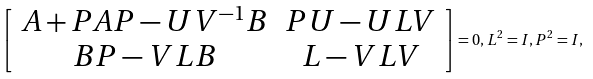Convert formula to latex. <formula><loc_0><loc_0><loc_500><loc_500>\left [ \begin{array} { c c } A + P A P - U V ^ { - 1 } B & P U - U L V \\ B P - V L B & L - V L V \end{array} \right ] = 0 , L ^ { 2 } = I , P ^ { 2 } = I ,</formula> 